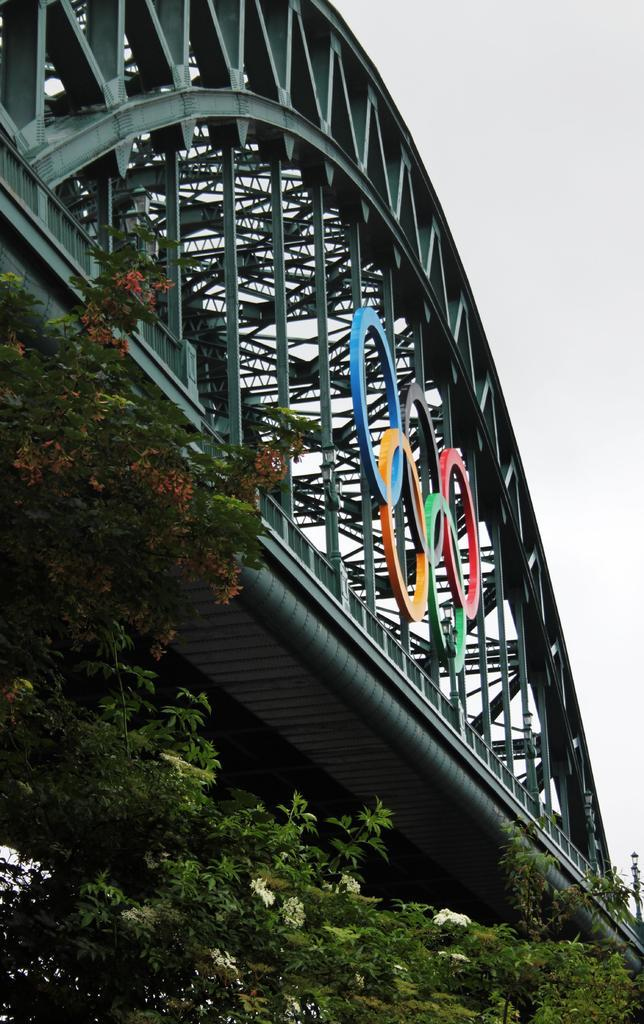What type of living organisms can be seen in the image? Plants can be seen in the image. How are the plants arranged in the image? The plants are arranged from left to right in the image. What additional feature can be seen in the image? There are colorful objects visible on a bridge in the image. Can you describe the snake that is biting the hand in the image? There is no snake or hand present in the image; it only features plants and a bridge with colorful objects. 